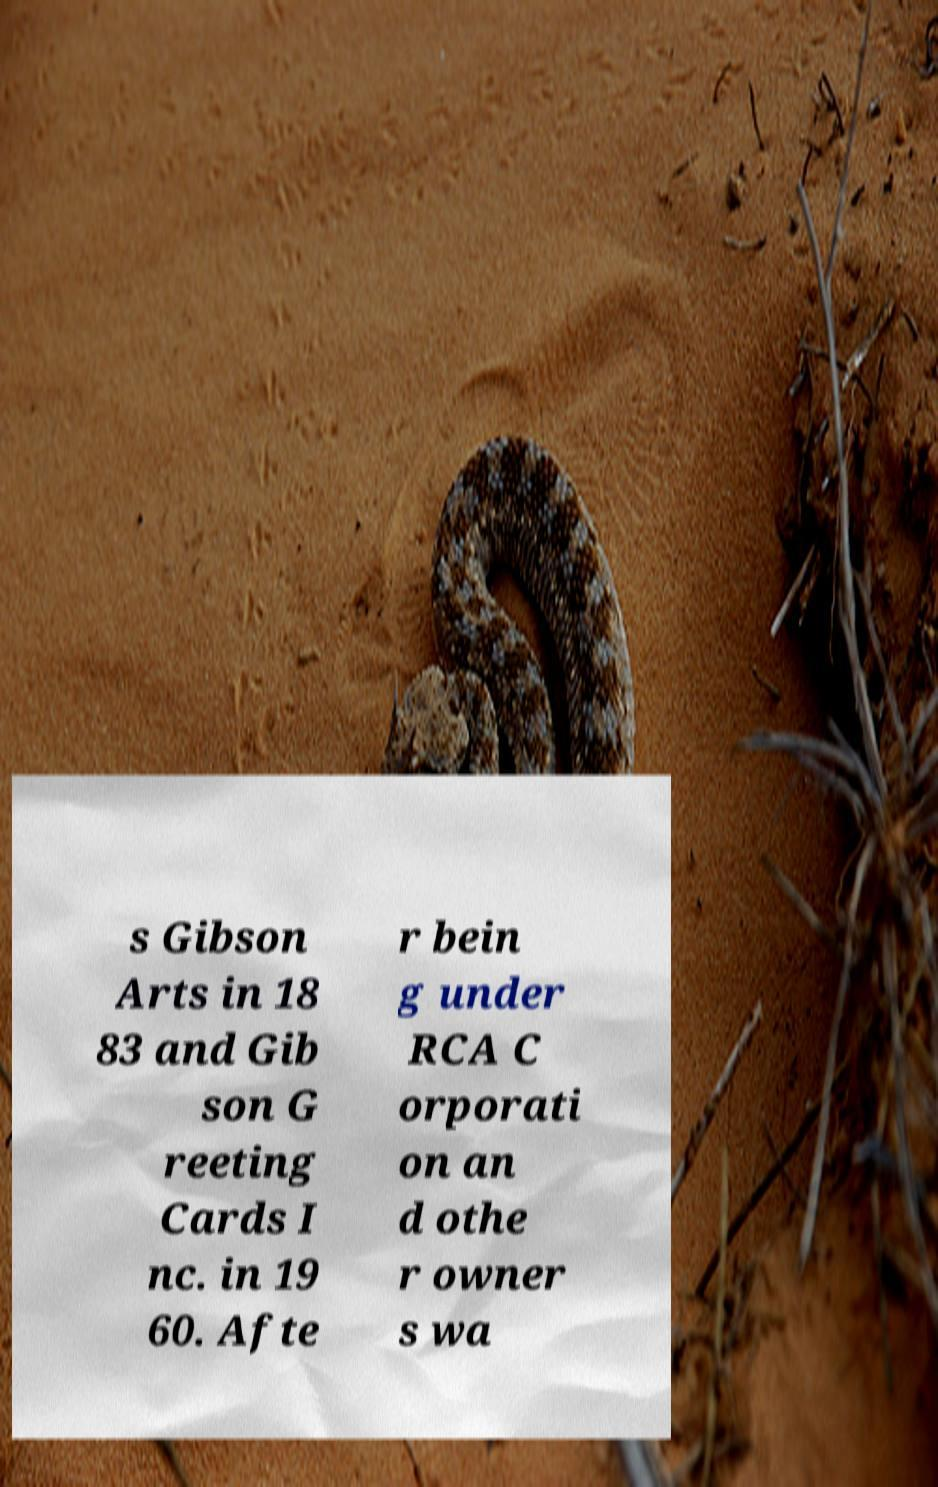For documentation purposes, I need the text within this image transcribed. Could you provide that? s Gibson Arts in 18 83 and Gib son G reeting Cards I nc. in 19 60. Afte r bein g under RCA C orporati on an d othe r owner s wa 